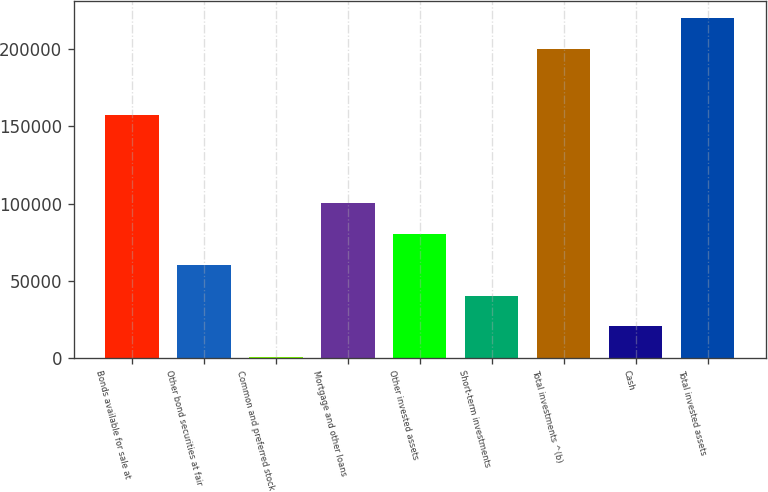Convert chart. <chart><loc_0><loc_0><loc_500><loc_500><bar_chart><fcel>Bonds available for sale at<fcel>Other bond securities at fair<fcel>Common and preferred stock<fcel>Mortgage and other loans<fcel>Other invested assets<fcel>Short-term investments<fcel>Total investments ^(b)<fcel>Cash<fcel>Total invested assets<nl><fcel>157150<fcel>60309<fcel>144<fcel>100419<fcel>80364<fcel>40254<fcel>200137<fcel>20199<fcel>220192<nl></chart> 